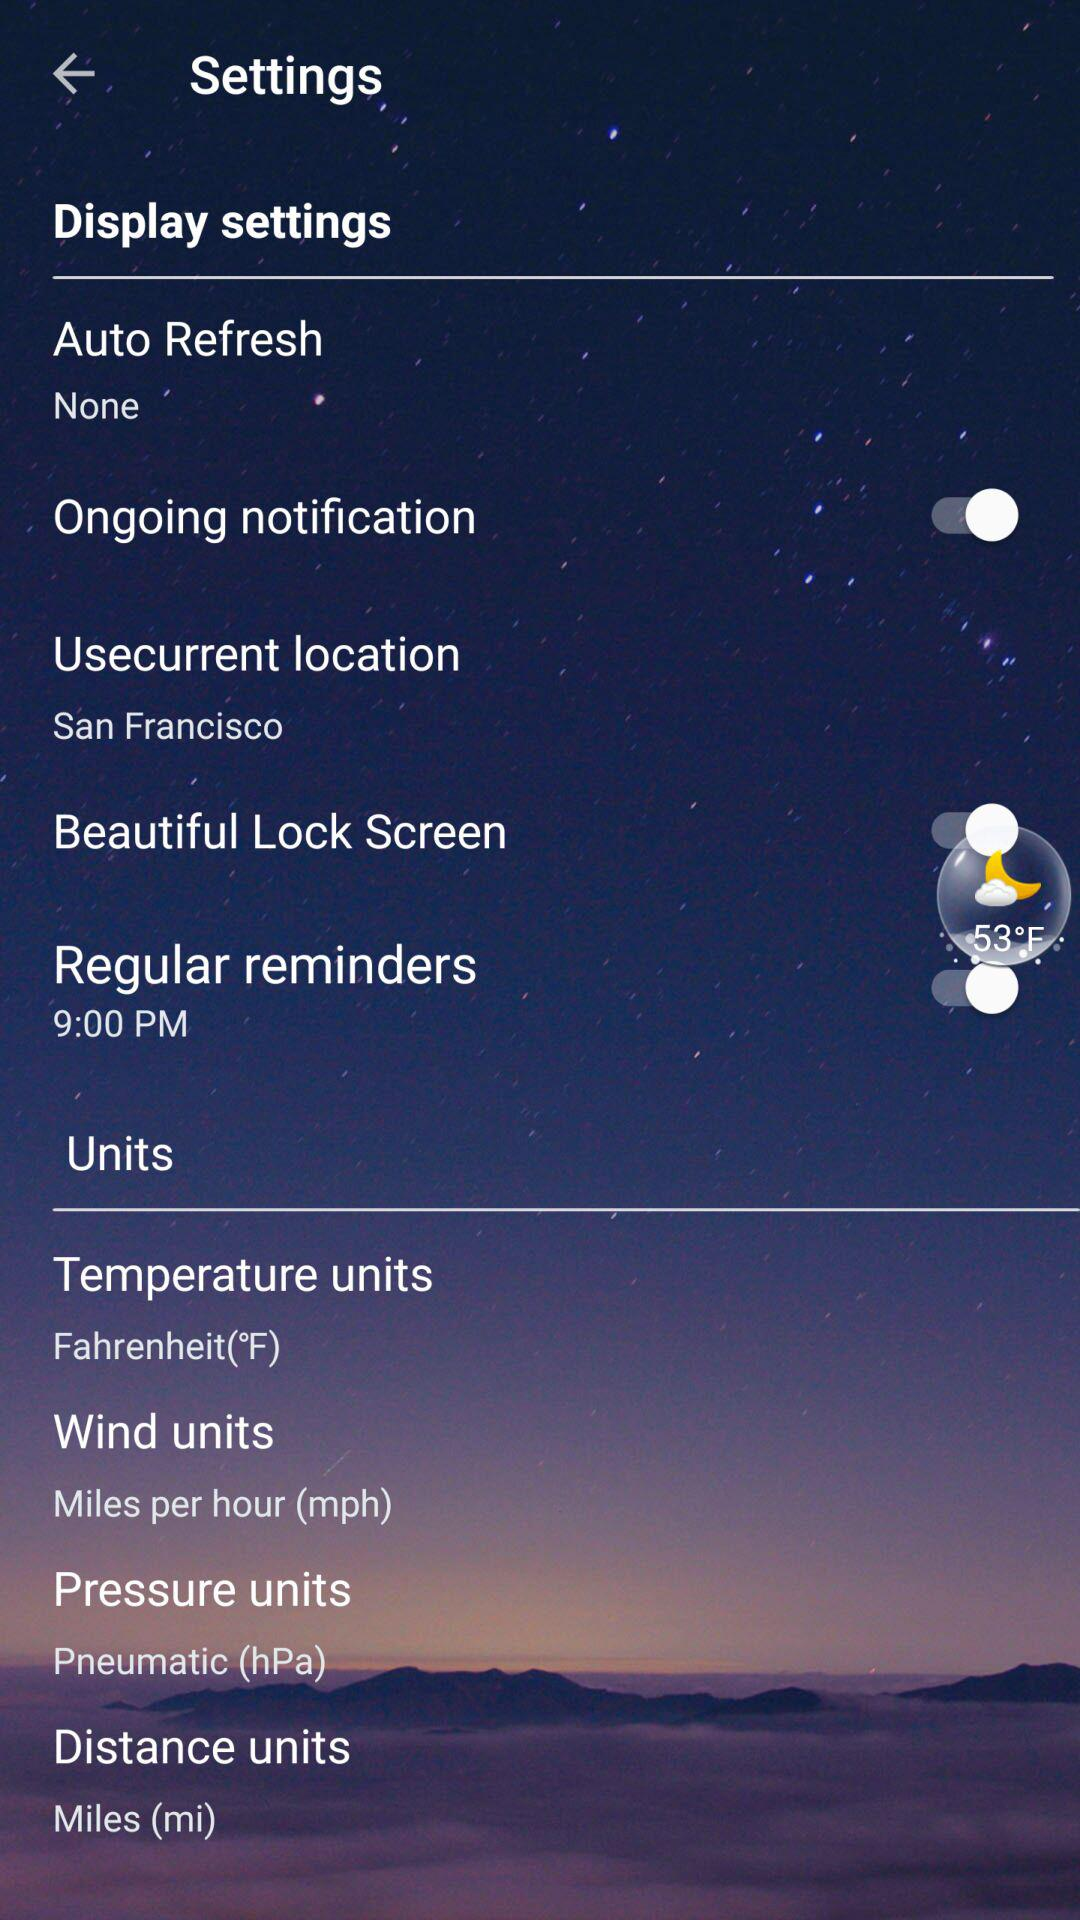What is the unit of temperature? The unit of temperature is Fahrenheit. 